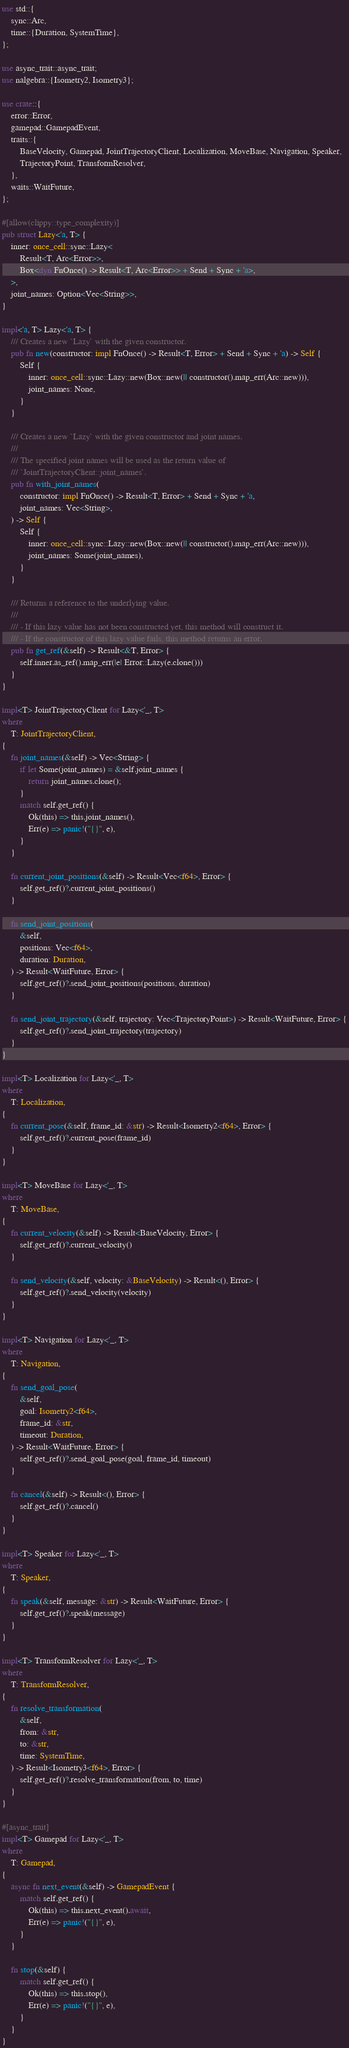<code> <loc_0><loc_0><loc_500><loc_500><_Rust_>use std::{
    sync::Arc,
    time::{Duration, SystemTime},
};

use async_trait::async_trait;
use nalgebra::{Isometry2, Isometry3};

use crate::{
    error::Error,
    gamepad::GamepadEvent,
    traits::{
        BaseVelocity, Gamepad, JointTrajectoryClient, Localization, MoveBase, Navigation, Speaker,
        TrajectoryPoint, TransformResolver,
    },
    waits::WaitFuture,
};

#[allow(clippy::type_complexity)]
pub struct Lazy<'a, T> {
    inner: once_cell::sync::Lazy<
        Result<T, Arc<Error>>,
        Box<dyn FnOnce() -> Result<T, Arc<Error>> + Send + Sync + 'a>,
    >,
    joint_names: Option<Vec<String>>,
}

impl<'a, T> Lazy<'a, T> {
    /// Creates a new `Lazy` with the given constructor.
    pub fn new(constructor: impl FnOnce() -> Result<T, Error> + Send + Sync + 'a) -> Self {
        Self {
            inner: once_cell::sync::Lazy::new(Box::new(|| constructor().map_err(Arc::new))),
            joint_names: None,
        }
    }

    /// Creates a new `Lazy` with the given constructor and joint names.
    ///
    /// The specified joint names will be used as the return value of
    /// `JointTrajectoryClient::joint_names`.
    pub fn with_joint_names(
        constructor: impl FnOnce() -> Result<T, Error> + Send + Sync + 'a,
        joint_names: Vec<String>,
    ) -> Self {
        Self {
            inner: once_cell::sync::Lazy::new(Box::new(|| constructor().map_err(Arc::new))),
            joint_names: Some(joint_names),
        }
    }

    /// Returns a reference to the underlying value.
    ///
    /// - If this lazy value has not been constructed yet, this method will construct it.
    /// - If the constructor of this lazy value fails, this method returns an error.
    pub fn get_ref(&self) -> Result<&T, Error> {
        self.inner.as_ref().map_err(|e| Error::Lazy(e.clone()))
    }
}

impl<T> JointTrajectoryClient for Lazy<'_, T>
where
    T: JointTrajectoryClient,
{
    fn joint_names(&self) -> Vec<String> {
        if let Some(joint_names) = &self.joint_names {
            return joint_names.clone();
        }
        match self.get_ref() {
            Ok(this) => this.joint_names(),
            Err(e) => panic!("{}", e),
        }
    }

    fn current_joint_positions(&self) -> Result<Vec<f64>, Error> {
        self.get_ref()?.current_joint_positions()
    }

    fn send_joint_positions(
        &self,
        positions: Vec<f64>,
        duration: Duration,
    ) -> Result<WaitFuture, Error> {
        self.get_ref()?.send_joint_positions(positions, duration)
    }

    fn send_joint_trajectory(&self, trajectory: Vec<TrajectoryPoint>) -> Result<WaitFuture, Error> {
        self.get_ref()?.send_joint_trajectory(trajectory)
    }
}

impl<T> Localization for Lazy<'_, T>
where
    T: Localization,
{
    fn current_pose(&self, frame_id: &str) -> Result<Isometry2<f64>, Error> {
        self.get_ref()?.current_pose(frame_id)
    }
}

impl<T> MoveBase for Lazy<'_, T>
where
    T: MoveBase,
{
    fn current_velocity(&self) -> Result<BaseVelocity, Error> {
        self.get_ref()?.current_velocity()
    }

    fn send_velocity(&self, velocity: &BaseVelocity) -> Result<(), Error> {
        self.get_ref()?.send_velocity(velocity)
    }
}

impl<T> Navigation for Lazy<'_, T>
where
    T: Navigation,
{
    fn send_goal_pose(
        &self,
        goal: Isometry2<f64>,
        frame_id: &str,
        timeout: Duration,
    ) -> Result<WaitFuture, Error> {
        self.get_ref()?.send_goal_pose(goal, frame_id, timeout)
    }

    fn cancel(&self) -> Result<(), Error> {
        self.get_ref()?.cancel()
    }
}

impl<T> Speaker for Lazy<'_, T>
where
    T: Speaker,
{
    fn speak(&self, message: &str) -> Result<WaitFuture, Error> {
        self.get_ref()?.speak(message)
    }
}

impl<T> TransformResolver for Lazy<'_, T>
where
    T: TransformResolver,
{
    fn resolve_transformation(
        &self,
        from: &str,
        to: &str,
        time: SystemTime,
    ) -> Result<Isometry3<f64>, Error> {
        self.get_ref()?.resolve_transformation(from, to, time)
    }
}

#[async_trait]
impl<T> Gamepad for Lazy<'_, T>
where
    T: Gamepad,
{
    async fn next_event(&self) -> GamepadEvent {
        match self.get_ref() {
            Ok(this) => this.next_event().await,
            Err(e) => panic!("{}", e),
        }
    }

    fn stop(&self) {
        match self.get_ref() {
            Ok(this) => this.stop(),
            Err(e) => panic!("{}", e),
        }
    }
}
</code> 